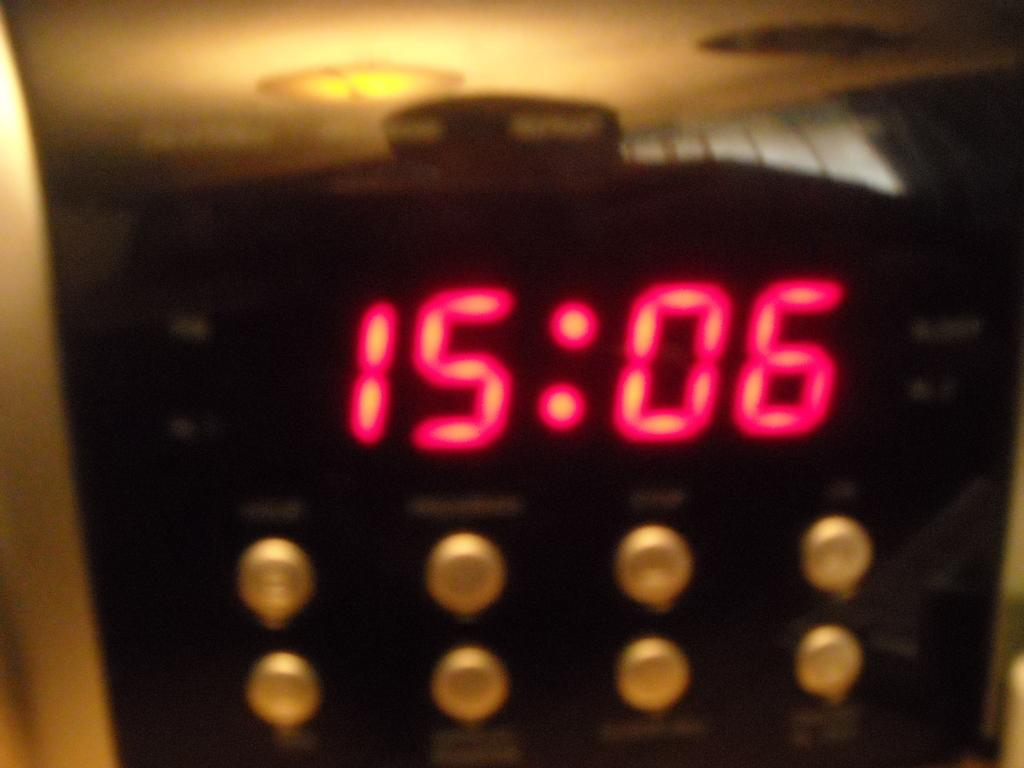<image>
Relay a brief, clear account of the picture shown. close up of black panel with 8 buttons and digital display showing 15:06 